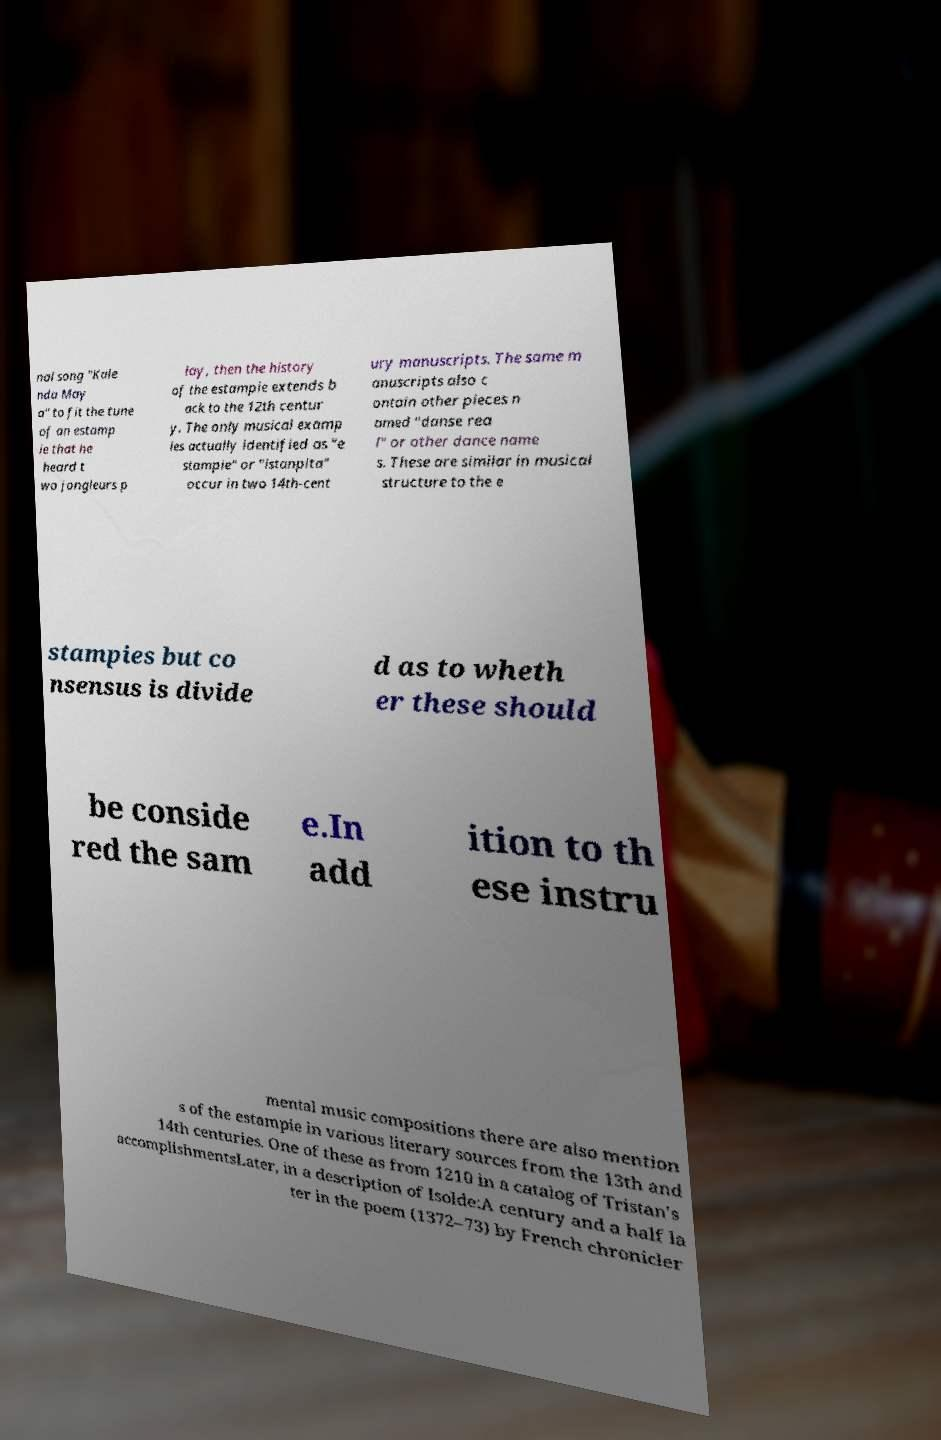Could you assist in decoding the text presented in this image and type it out clearly? nal song "Kale nda May a" to fit the tune of an estamp ie that he heard t wo jongleurs p lay, then the history of the estampie extends b ack to the 12th centur y. The only musical examp les actually identified as "e stampie" or "istanpita" occur in two 14th-cent ury manuscripts. The same m anuscripts also c ontain other pieces n amed "danse rea l" or other dance name s. These are similar in musical structure to the e stampies but co nsensus is divide d as to wheth er these should be conside red the sam e.In add ition to th ese instru mental music compositions there are also mention s of the estampie in various literary sources from the 13th and 14th centuries. One of these as from 1210 in a catalog of Tristan's accomplishmentsLater, in a description of Isolde:A century and a half la ter in the poem (1372–73) by French chronicler 